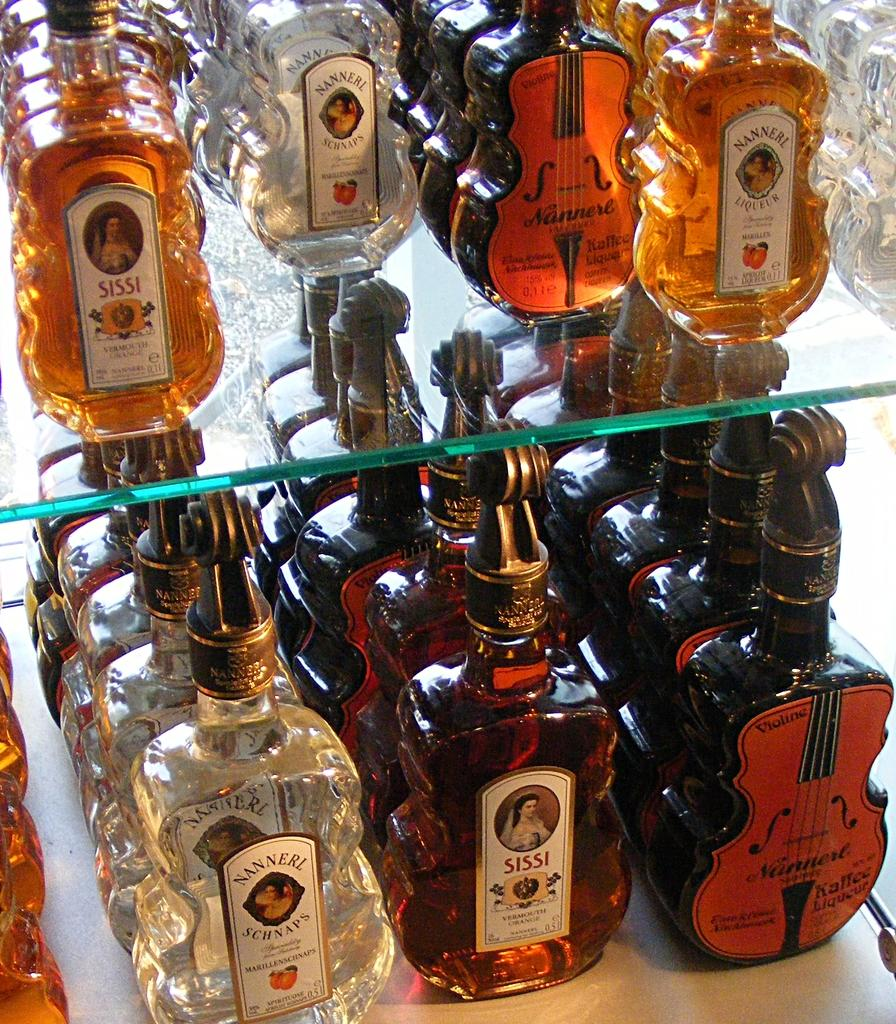What is the shape of the glass bottles in the image? The glass bottles in the image are violin-shaped. What can be observed about the colors of the bottles? The bottles are of different colors. How are the bottles arranged in the image? The bottles are arranged one above the other. Can you describe any variations in the shapes of the bottles? The bottles are of different shapes. What type of fruit is being used to clean the bottles in the image? There is no fruit present in the image, and the bottles are not being cleaned. 